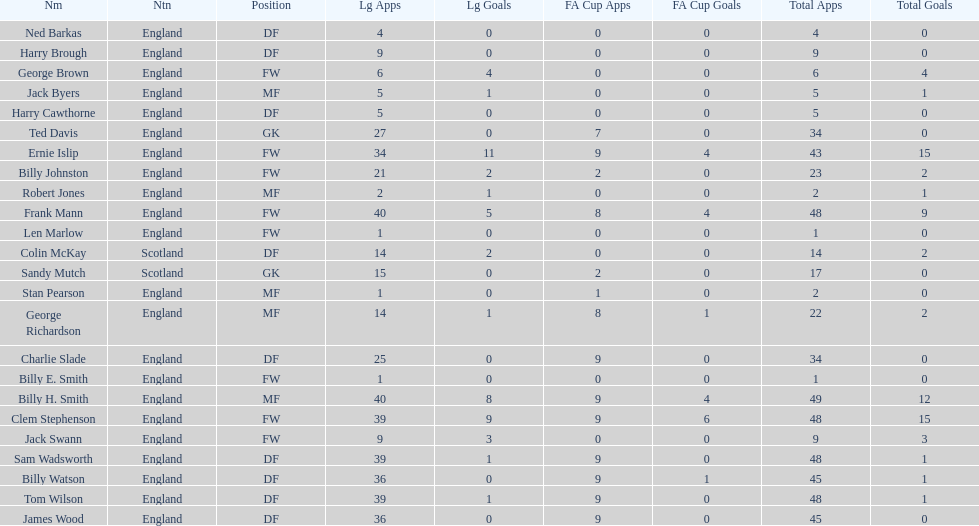What is the average number of scotland's total apps? 15.5. 